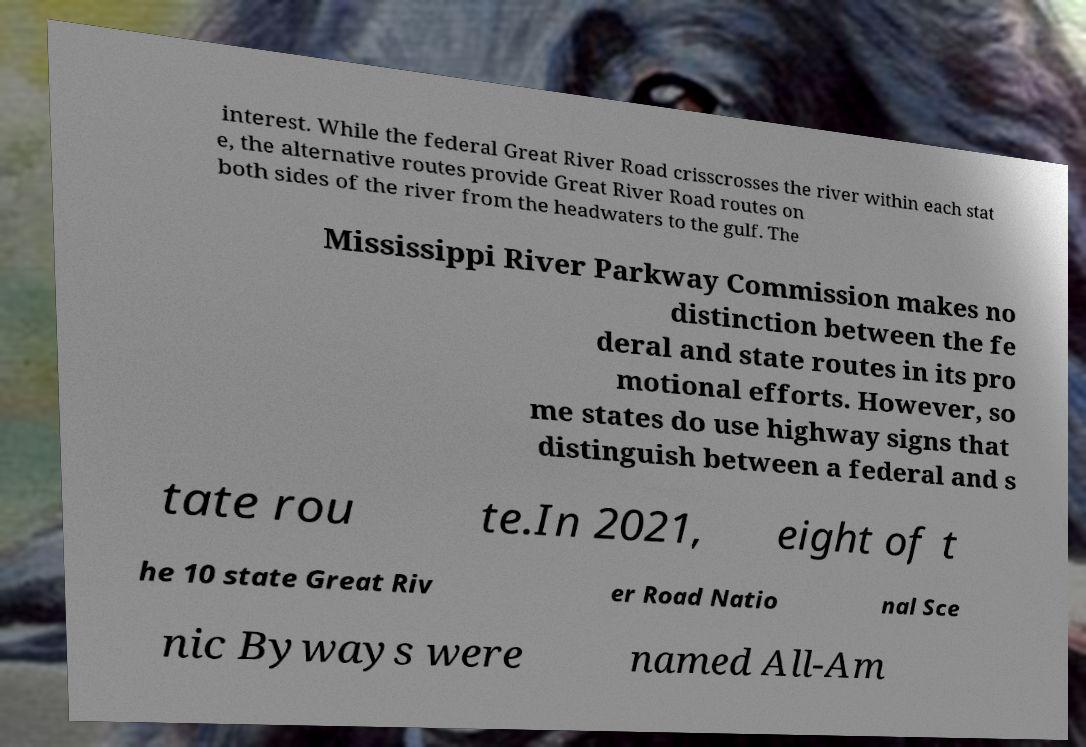Please read and relay the text visible in this image. What does it say? interest. While the federal Great River Road crisscrosses the river within each stat e, the alternative routes provide Great River Road routes on both sides of the river from the headwaters to the gulf. The Mississippi River Parkway Commission makes no distinction between the fe deral and state routes in its pro motional efforts. However, so me states do use highway signs that distinguish between a federal and s tate rou te.In 2021, eight of t he 10 state Great Riv er Road Natio nal Sce nic Byways were named All-Am 